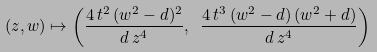Convert formula to latex. <formula><loc_0><loc_0><loc_500><loc_500>( z , w ) \mapsto \left ( \frac { 4 \, t ^ { 2 } \, ( w ^ { 2 } - d ) ^ { 2 } } { d \, z ^ { 4 } } , \ \frac { 4 \, t ^ { 3 } \, ( w ^ { 2 } - d ) \, ( w ^ { 2 } + d ) } { d \, z ^ { 4 } } \right )</formula> 